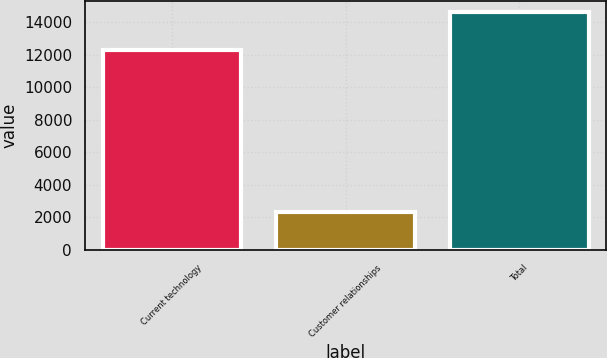<chart> <loc_0><loc_0><loc_500><loc_500><bar_chart><fcel>Current technology<fcel>Customer relationships<fcel>Total<nl><fcel>12258<fcel>2333<fcel>14591<nl></chart> 